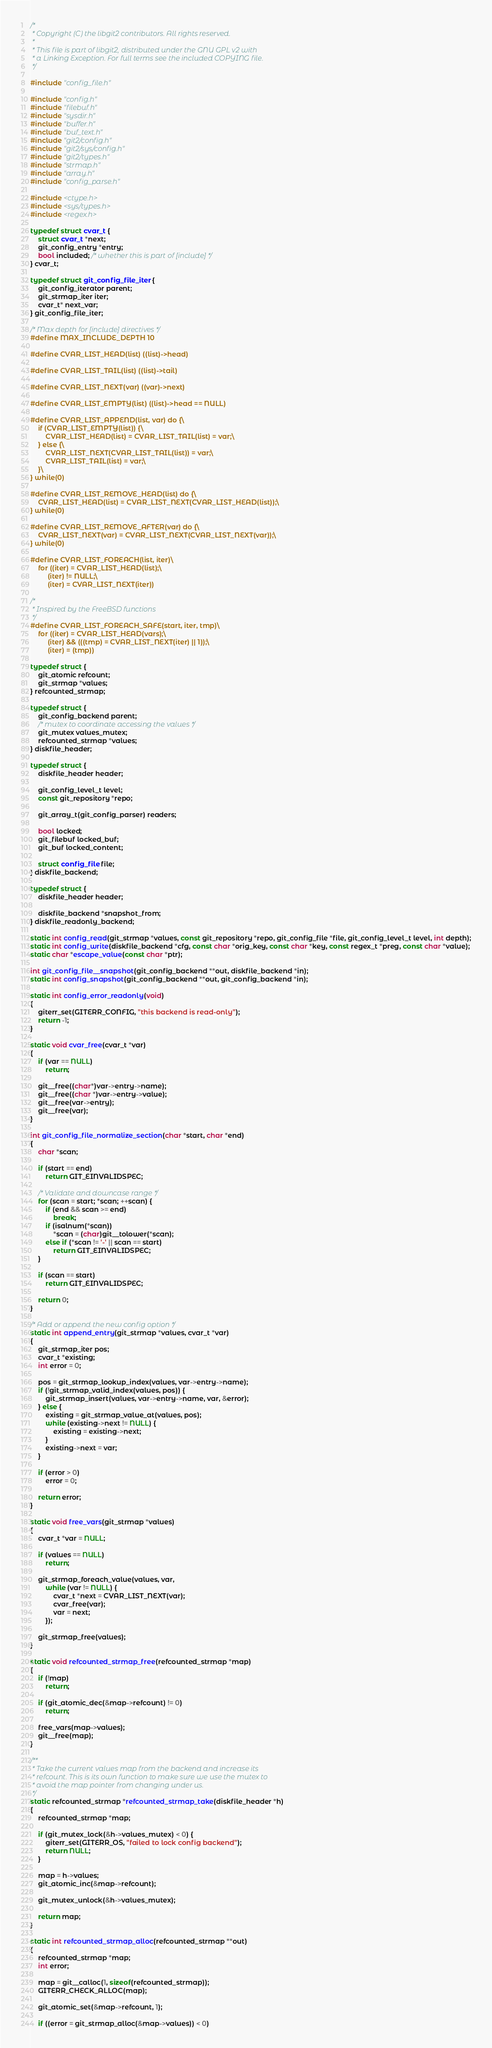<code> <loc_0><loc_0><loc_500><loc_500><_C_>/*
 * Copyright (C) the libgit2 contributors. All rights reserved.
 *
 * This file is part of libgit2, distributed under the GNU GPL v2 with
 * a Linking Exception. For full terms see the included COPYING file.
 */

#include "config_file.h"

#include "config.h"
#include "filebuf.h"
#include "sysdir.h"
#include "buffer.h"
#include "buf_text.h"
#include "git2/config.h"
#include "git2/sys/config.h"
#include "git2/types.h"
#include "strmap.h"
#include "array.h"
#include "config_parse.h"

#include <ctype.h>
#include <sys/types.h>
#include <regex.h>

typedef struct cvar_t {
	struct cvar_t *next;
	git_config_entry *entry;
	bool included; /* whether this is part of [include] */
} cvar_t;

typedef struct git_config_file_iter {
	git_config_iterator parent;
	git_strmap_iter iter;
	cvar_t* next_var;
} git_config_file_iter;

/* Max depth for [include] directives */
#define MAX_INCLUDE_DEPTH 10

#define CVAR_LIST_HEAD(list) ((list)->head)

#define CVAR_LIST_TAIL(list) ((list)->tail)

#define CVAR_LIST_NEXT(var) ((var)->next)

#define CVAR_LIST_EMPTY(list) ((list)->head == NULL)

#define CVAR_LIST_APPEND(list, var) do {\
	if (CVAR_LIST_EMPTY(list)) {\
		CVAR_LIST_HEAD(list) = CVAR_LIST_TAIL(list) = var;\
	} else {\
		CVAR_LIST_NEXT(CVAR_LIST_TAIL(list)) = var;\
		CVAR_LIST_TAIL(list) = var;\
	}\
} while(0)

#define CVAR_LIST_REMOVE_HEAD(list) do {\
	CVAR_LIST_HEAD(list) = CVAR_LIST_NEXT(CVAR_LIST_HEAD(list));\
} while(0)

#define CVAR_LIST_REMOVE_AFTER(var) do {\
	CVAR_LIST_NEXT(var) = CVAR_LIST_NEXT(CVAR_LIST_NEXT(var));\
} while(0)

#define CVAR_LIST_FOREACH(list, iter)\
	for ((iter) = CVAR_LIST_HEAD(list);\
		 (iter) != NULL;\
		 (iter) = CVAR_LIST_NEXT(iter))

/*
 * Inspired by the FreeBSD functions
 */
#define CVAR_LIST_FOREACH_SAFE(start, iter, tmp)\
	for ((iter) = CVAR_LIST_HEAD(vars);\
		 (iter) && (((tmp) = CVAR_LIST_NEXT(iter) || 1));\
		 (iter) = (tmp))

typedef struct {
	git_atomic refcount;
	git_strmap *values;
} refcounted_strmap;

typedef struct {
	git_config_backend parent;
	/* mutex to coordinate accessing the values */
	git_mutex values_mutex;
	refcounted_strmap *values;
} diskfile_header;

typedef struct {
	diskfile_header header;

	git_config_level_t level;
	const git_repository *repo;

	git_array_t(git_config_parser) readers;

	bool locked;
	git_filebuf locked_buf;
	git_buf locked_content;

	struct config_file file;
} diskfile_backend;

typedef struct {
	diskfile_header header;

	diskfile_backend *snapshot_from;
} diskfile_readonly_backend;

static int config_read(git_strmap *values, const git_repository *repo, git_config_file *file, git_config_level_t level, int depth);
static int config_write(diskfile_backend *cfg, const char *orig_key, const char *key, const regex_t *preg, const char *value);
static char *escape_value(const char *ptr);

int git_config_file__snapshot(git_config_backend **out, diskfile_backend *in);
static int config_snapshot(git_config_backend **out, git_config_backend *in);

static int config_error_readonly(void)
{
	giterr_set(GITERR_CONFIG, "this backend is read-only");
	return -1;
}

static void cvar_free(cvar_t *var)
{
	if (var == NULL)
		return;

	git__free((char*)var->entry->name);
	git__free((char *)var->entry->value);
	git__free(var->entry);
	git__free(var);
}

int git_config_file_normalize_section(char *start, char *end)
{
	char *scan;

	if (start == end)
		return GIT_EINVALIDSPEC;

	/* Validate and downcase range */
	for (scan = start; *scan; ++scan) {
		if (end && scan >= end)
			break;
		if (isalnum(*scan))
			*scan = (char)git__tolower(*scan);
		else if (*scan != '-' || scan == start)
			return GIT_EINVALIDSPEC;
	}

	if (scan == start)
		return GIT_EINVALIDSPEC;

	return 0;
}

/* Add or append the new config option */
static int append_entry(git_strmap *values, cvar_t *var)
{
	git_strmap_iter pos;
	cvar_t *existing;
	int error = 0;

	pos = git_strmap_lookup_index(values, var->entry->name);
	if (!git_strmap_valid_index(values, pos)) {
		git_strmap_insert(values, var->entry->name, var, &error);
	} else {
		existing = git_strmap_value_at(values, pos);
		while (existing->next != NULL) {
			existing = existing->next;
		}
		existing->next = var;
	}

	if (error > 0)
		error = 0;

	return error;
}

static void free_vars(git_strmap *values)
{
	cvar_t *var = NULL;

	if (values == NULL)
		return;

	git_strmap_foreach_value(values, var,
		while (var != NULL) {
			cvar_t *next = CVAR_LIST_NEXT(var);
			cvar_free(var);
			var = next;
		});

	git_strmap_free(values);
}

static void refcounted_strmap_free(refcounted_strmap *map)
{
	if (!map)
		return;

	if (git_atomic_dec(&map->refcount) != 0)
		return;

	free_vars(map->values);
	git__free(map);
}

/**
 * Take the current values map from the backend and increase its
 * refcount. This is its own function to make sure we use the mutex to
 * avoid the map pointer from changing under us.
 */
static refcounted_strmap *refcounted_strmap_take(diskfile_header *h)
{
	refcounted_strmap *map;

	if (git_mutex_lock(&h->values_mutex) < 0) {
	    giterr_set(GITERR_OS, "failed to lock config backend");
	    return NULL;
	}

	map = h->values;
	git_atomic_inc(&map->refcount);

	git_mutex_unlock(&h->values_mutex);

	return map;
}

static int refcounted_strmap_alloc(refcounted_strmap **out)
{
	refcounted_strmap *map;
	int error;

	map = git__calloc(1, sizeof(refcounted_strmap));
	GITERR_CHECK_ALLOC(map);

	git_atomic_set(&map->refcount, 1);

	if ((error = git_strmap_alloc(&map->values)) < 0)</code> 